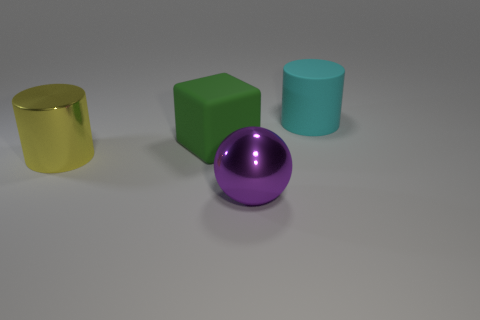Subtract 1 cubes. How many cubes are left? 0 Add 3 big yellow cylinders. How many objects exist? 7 Subtract 0 gray balls. How many objects are left? 4 Subtract all spheres. How many objects are left? 3 Subtract all yellow cubes. Subtract all blue cylinders. How many cubes are left? 1 Subtract all purple balls. How many yellow cylinders are left? 1 Subtract all metallic things. Subtract all big purple metal cylinders. How many objects are left? 2 Add 3 big purple spheres. How many big purple spheres are left? 4 Add 1 big brown things. How many big brown things exist? 1 